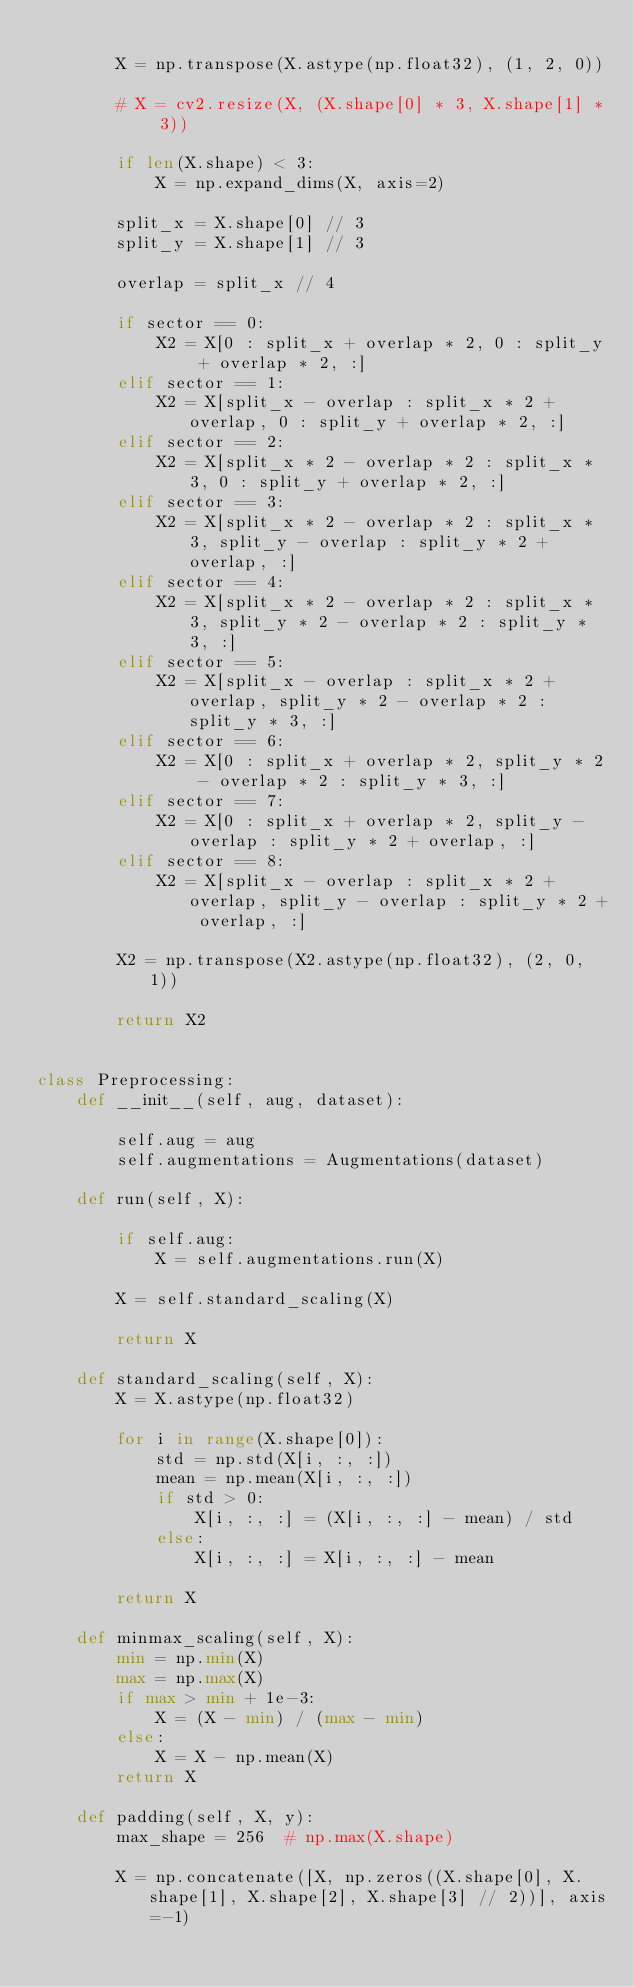<code> <loc_0><loc_0><loc_500><loc_500><_Python_>
        X = np.transpose(X.astype(np.float32), (1, 2, 0))

        # X = cv2.resize(X, (X.shape[0] * 3, X.shape[1] * 3))

        if len(X.shape) < 3:
            X = np.expand_dims(X, axis=2)

        split_x = X.shape[0] // 3
        split_y = X.shape[1] // 3

        overlap = split_x // 4

        if sector == 0:
            X2 = X[0 : split_x + overlap * 2, 0 : split_y + overlap * 2, :]
        elif sector == 1:
            X2 = X[split_x - overlap : split_x * 2 + overlap, 0 : split_y + overlap * 2, :]
        elif sector == 2:
            X2 = X[split_x * 2 - overlap * 2 : split_x * 3, 0 : split_y + overlap * 2, :]
        elif sector == 3:
            X2 = X[split_x * 2 - overlap * 2 : split_x * 3, split_y - overlap : split_y * 2 + overlap, :]
        elif sector == 4:
            X2 = X[split_x * 2 - overlap * 2 : split_x * 3, split_y * 2 - overlap * 2 : split_y * 3, :]
        elif sector == 5:
            X2 = X[split_x - overlap : split_x * 2 + overlap, split_y * 2 - overlap * 2 : split_y * 3, :]
        elif sector == 6:
            X2 = X[0 : split_x + overlap * 2, split_y * 2 - overlap * 2 : split_y * 3, :]
        elif sector == 7:
            X2 = X[0 : split_x + overlap * 2, split_y - overlap : split_y * 2 + overlap, :]
        elif sector == 8:
            X2 = X[split_x - overlap : split_x * 2 + overlap, split_y - overlap : split_y * 2 + overlap, :]

        X2 = np.transpose(X2.astype(np.float32), (2, 0, 1))

        return X2


class Preprocessing:
    def __init__(self, aug, dataset):

        self.aug = aug
        self.augmentations = Augmentations(dataset)

    def run(self, X):

        if self.aug:
            X = self.augmentations.run(X)

        X = self.standard_scaling(X)

        return X

    def standard_scaling(self, X):
        X = X.astype(np.float32)

        for i in range(X.shape[0]):
            std = np.std(X[i, :, :])
            mean = np.mean(X[i, :, :])
            if std > 0:
                X[i, :, :] = (X[i, :, :] - mean) / std
            else:
                X[i, :, :] = X[i, :, :] - mean

        return X

    def minmax_scaling(self, X):
        min = np.min(X)
        max = np.max(X)
        if max > min + 1e-3:
            X = (X - min) / (max - min)
        else:
            X = X - np.mean(X)
        return X

    def padding(self, X, y):
        max_shape = 256  # np.max(X.shape)

        X = np.concatenate([X, np.zeros((X.shape[0], X.shape[1], X.shape[2], X.shape[3] // 2))], axis=-1)</code> 